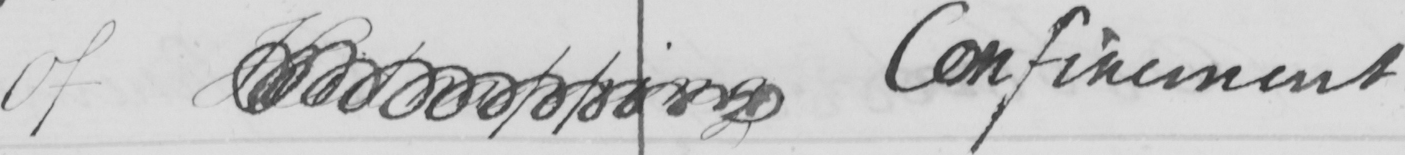What text is written in this handwritten line? Of Kidnapping Confinement . 